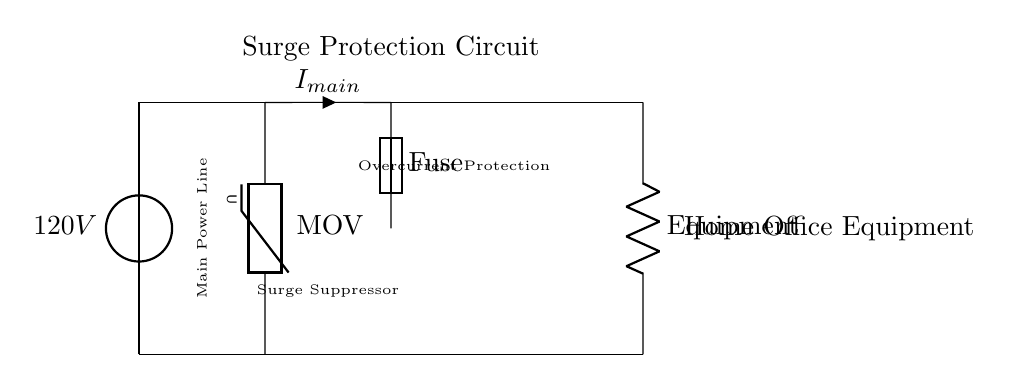What is the main voltage supply in this circuit? The diagram indicates a voltage source labeled as 120V connected at the top of the circuit. This is the main source of power for the entire circuit.
Answer: 120V What component is used for surge suppression? The circuit includes a varistor marked as MOV that connects from the main line to the ground, which serves to suppress voltage spikes.
Answer: MOV What does the fuse protect against? The fuse in the circuit provides overcurrent protection by breaking the circuit if the current exceeds a certain limit, thereby preventing potential damage to the devices connected to the circuit.
Answer: Overcurrent What is the purpose of the equipment load in this circuit? The "Equipment" resistor at the end of the circuit represents the devices in the home office that are powered by the circuit and are protected by the surge protection and fuse respectively.
Answer: Home Office Equipment How many main components are there in the circuit? Analyzing the diagram, the main components present are the voltage source, MOV, fuse, and the equipment load. This totals four primary components in the circuit.
Answer: 4 